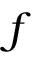<formula> <loc_0><loc_0><loc_500><loc_500>f</formula> 